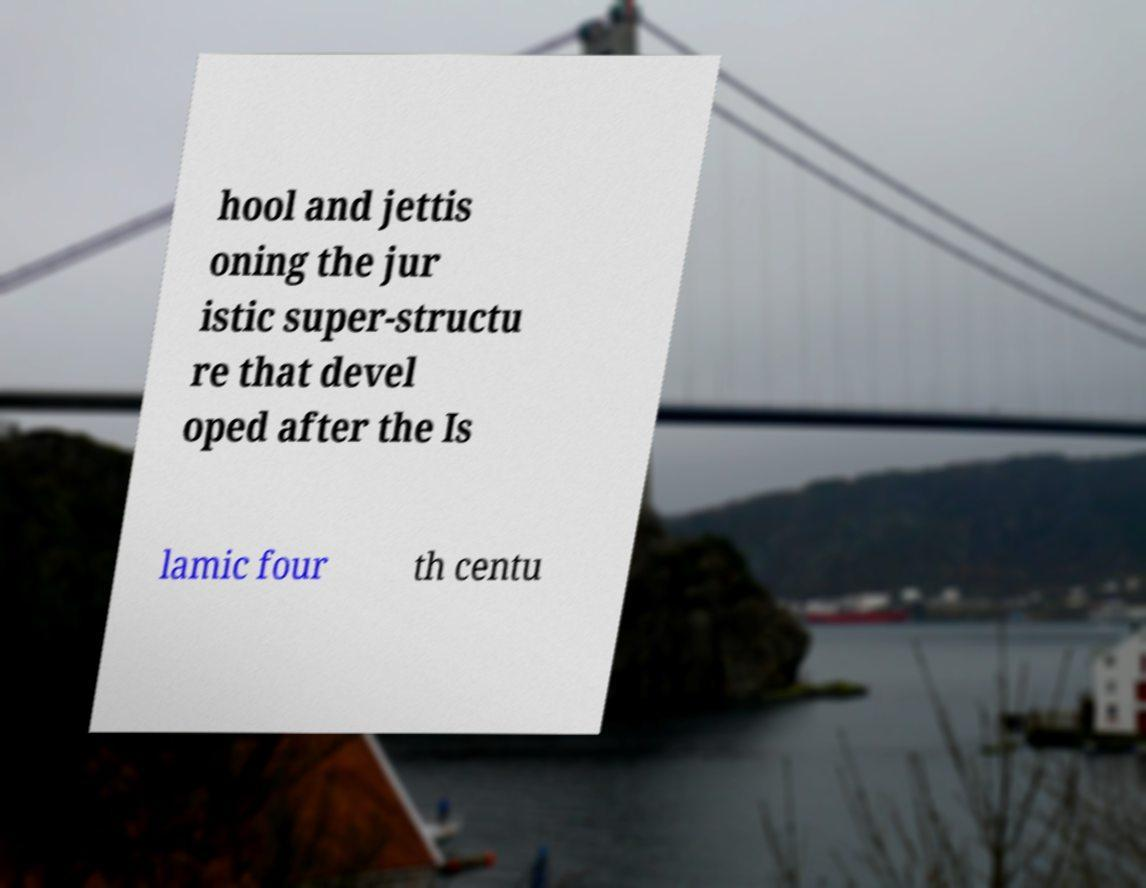Can you read and provide the text displayed in the image?This photo seems to have some interesting text. Can you extract and type it out for me? hool and jettis oning the jur istic super-structu re that devel oped after the Is lamic four th centu 